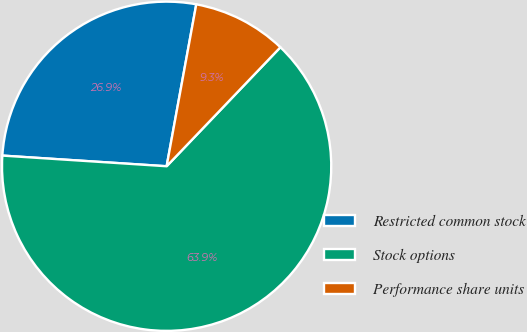Convert chart. <chart><loc_0><loc_0><loc_500><loc_500><pie_chart><fcel>Restricted common stock<fcel>Stock options<fcel>Performance share units<nl><fcel>26.85%<fcel>63.89%<fcel>9.26%<nl></chart> 